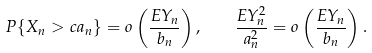<formula> <loc_0><loc_0><loc_500><loc_500>P \{ X _ { n } > c a _ { n } \} = o \left ( \frac { E Y _ { n } } { b _ { n } } \right ) , \quad \frac { E Y _ { n } ^ { 2 } } { a _ { n } ^ { 2 } } = o \left ( \frac { E Y _ { n } } { b _ { n } } \right ) .</formula> 